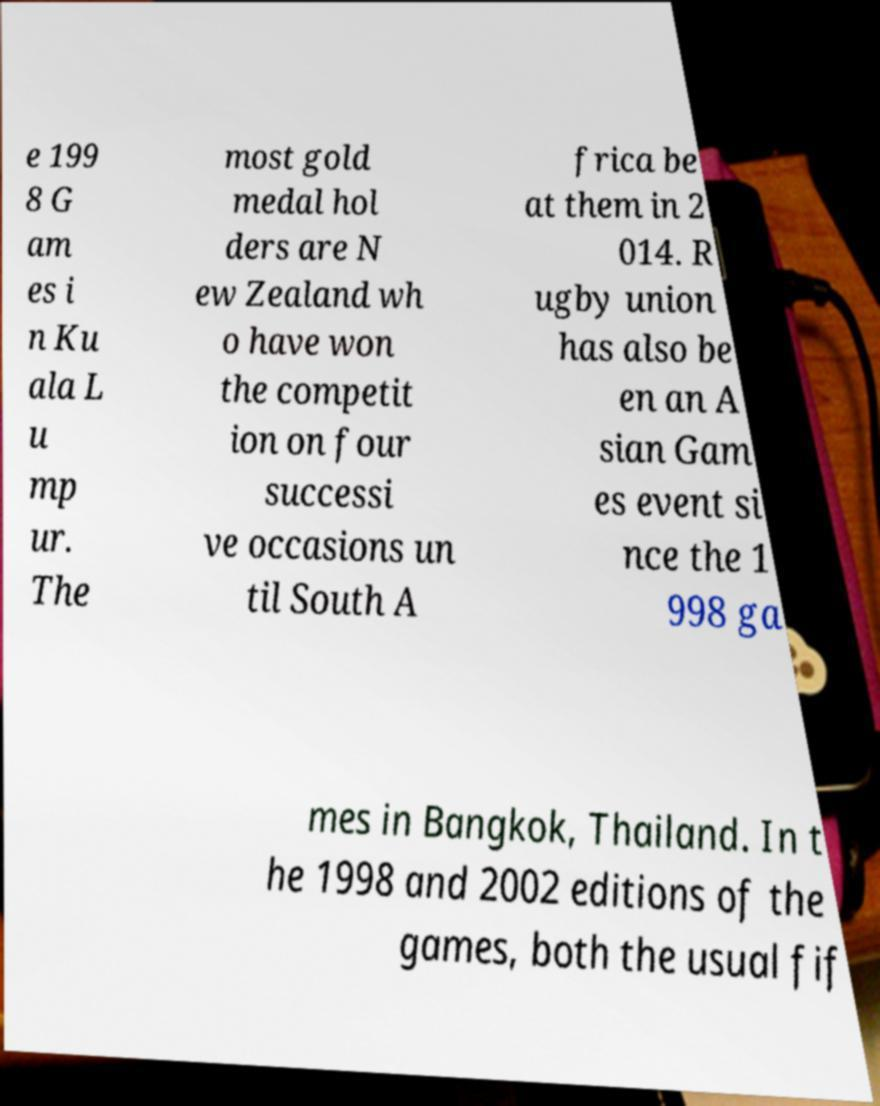Can you accurately transcribe the text from the provided image for me? e 199 8 G am es i n Ku ala L u mp ur. The most gold medal hol ders are N ew Zealand wh o have won the competit ion on four successi ve occasions un til South A frica be at them in 2 014. R ugby union has also be en an A sian Gam es event si nce the 1 998 ga mes in Bangkok, Thailand. In t he 1998 and 2002 editions of the games, both the usual fif 